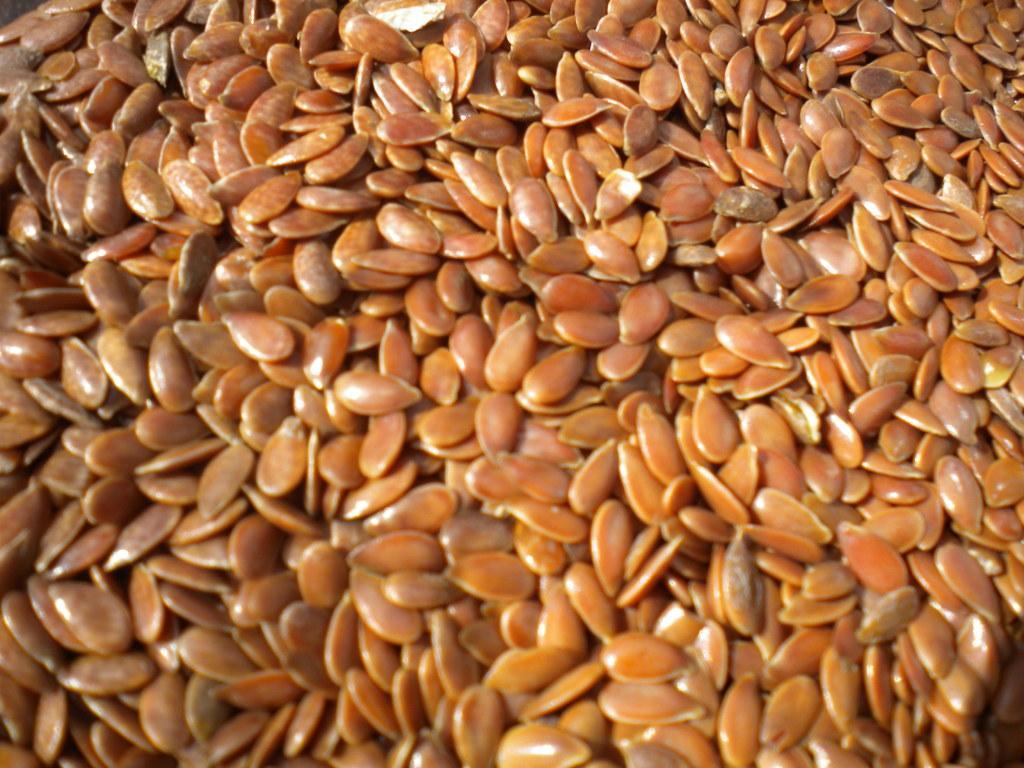Describe this image in one or two sentences. In this image we can see seeds. 